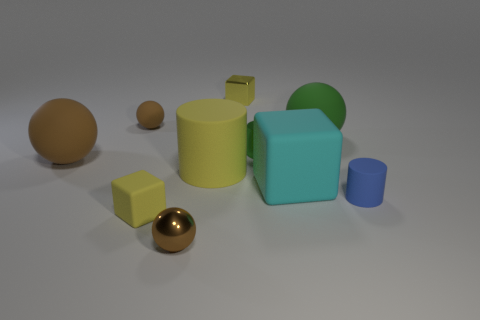Are there fewer objects that are on the left side of the large yellow matte object than green cylinders behind the cyan object?
Give a very brief answer. No. How many small green cylinders are there?
Your answer should be compact. 1. Is there any other thing that is the same material as the large green ball?
Keep it short and to the point. Yes. There is another tiny thing that is the same shape as the green metallic thing; what material is it?
Offer a very short reply. Rubber. Are there fewer brown spheres behind the small green metallic object than rubber spheres?
Offer a very short reply. Yes. Is the shape of the big thing to the left of the shiny ball the same as  the big green thing?
Offer a terse response. Yes. Are there any other things of the same color as the large cylinder?
Your response must be concise. Yes. What size is the blue cylinder that is the same material as the yellow cylinder?
Your answer should be very brief. Small. What is the material of the small yellow object to the right of the tiny brown ball right of the yellow thing left of the yellow matte cylinder?
Ensure brevity in your answer.  Metal. Are there fewer green metal balls than green cylinders?
Provide a succinct answer. Yes. 